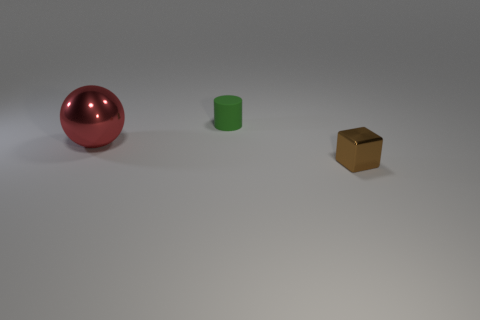Add 3 large green matte things. How many objects exist? 6 Subtract all cylinders. How many objects are left? 2 Add 3 large blue cylinders. How many large blue cylinders exist? 3 Subtract 0 blue cylinders. How many objects are left? 3 Subtract all brown metallic balls. Subtract all green matte cylinders. How many objects are left? 2 Add 2 tiny brown things. How many tiny brown things are left? 3 